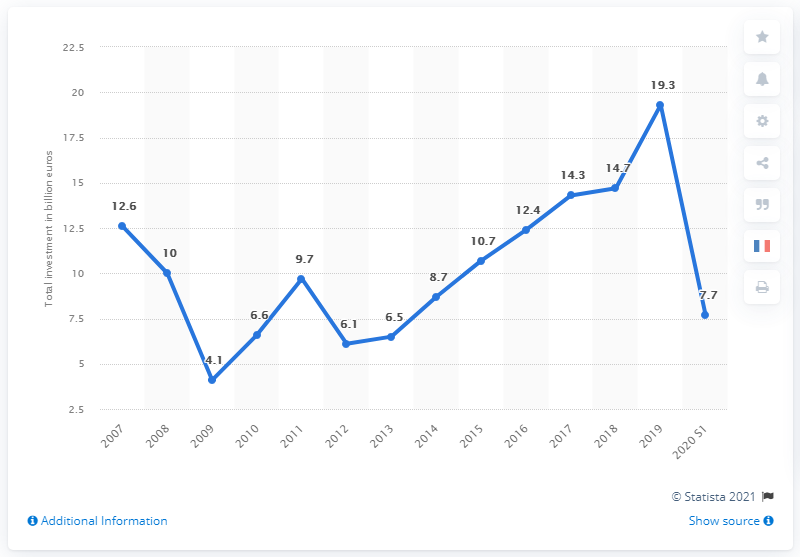Highlight a few significant elements in this photo. The smallest total value of private equity investments was found in 2009. 